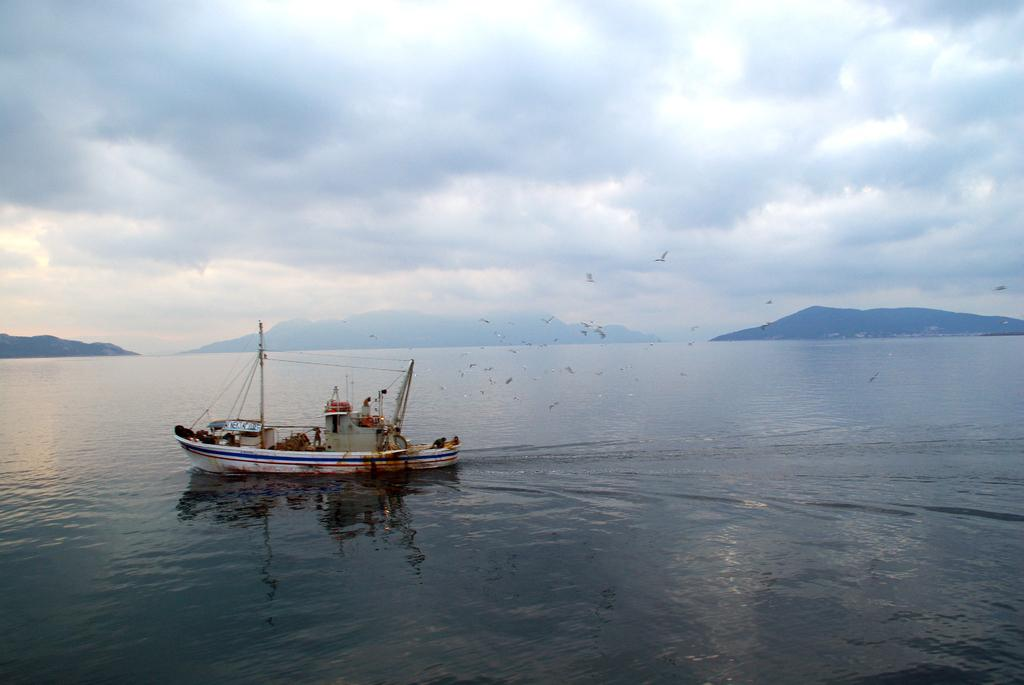What is the main subject of the image? The main subject of the image is a ship above the water. What else is happening in the image? Birds are flying in the air in the image. What can be seen in the distance in the image? There are hills visible in the background of the image. What is visible in the sky in the image? The sky is visible in the background of the image, and clouds are present. What type of apparatus is being used by the birds to fly in the image? There is no apparatus being used by the birds to fly in the image; they are using their natural ability to fly. What time does the watch in the image show? There is no watch present in the image. 